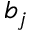Convert formula to latex. <formula><loc_0><loc_0><loc_500><loc_500>b _ { j }</formula> 